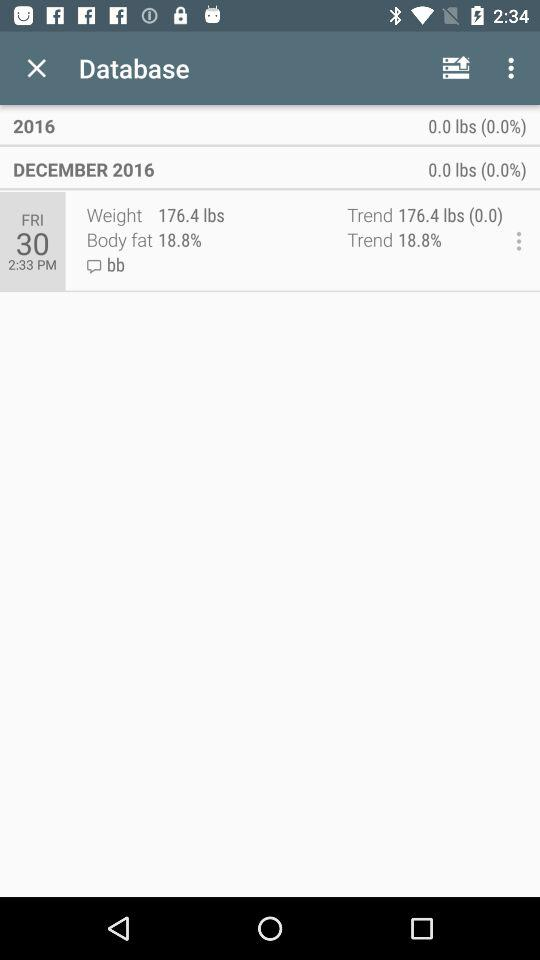How much weight has been lost since the beginning of the month?
Answer the question using a single word or phrase. 0.0 lbs 